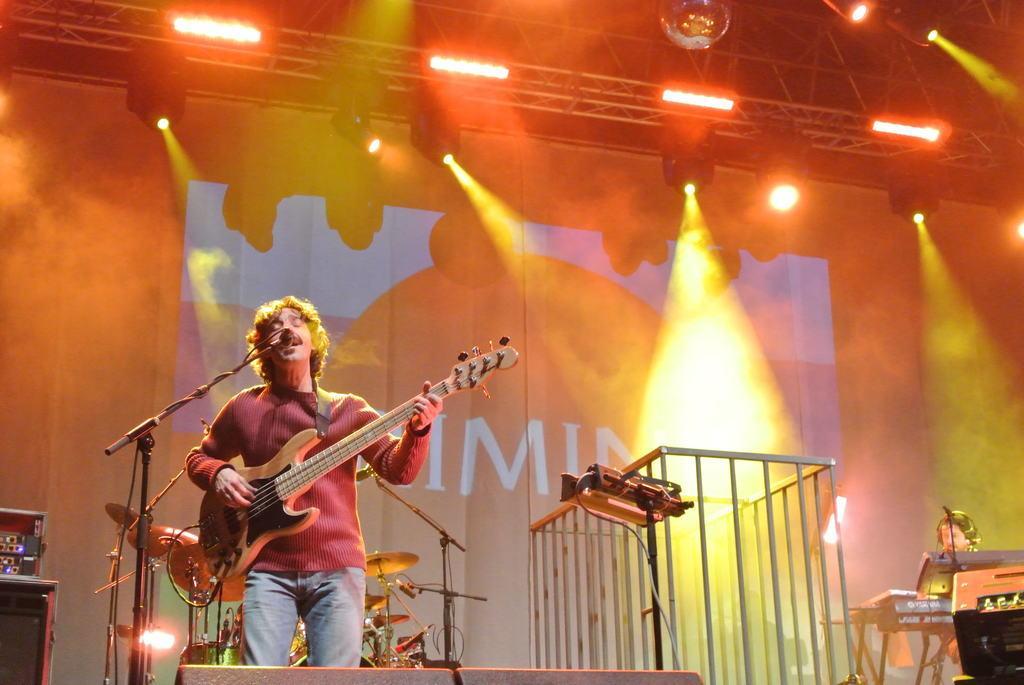Can you describe this image briefly? Here we can see a man is standing and playing the guitar and singing, and in front here is the microphone and stand, and at back here are the musical drums, and at above here are the lights. 